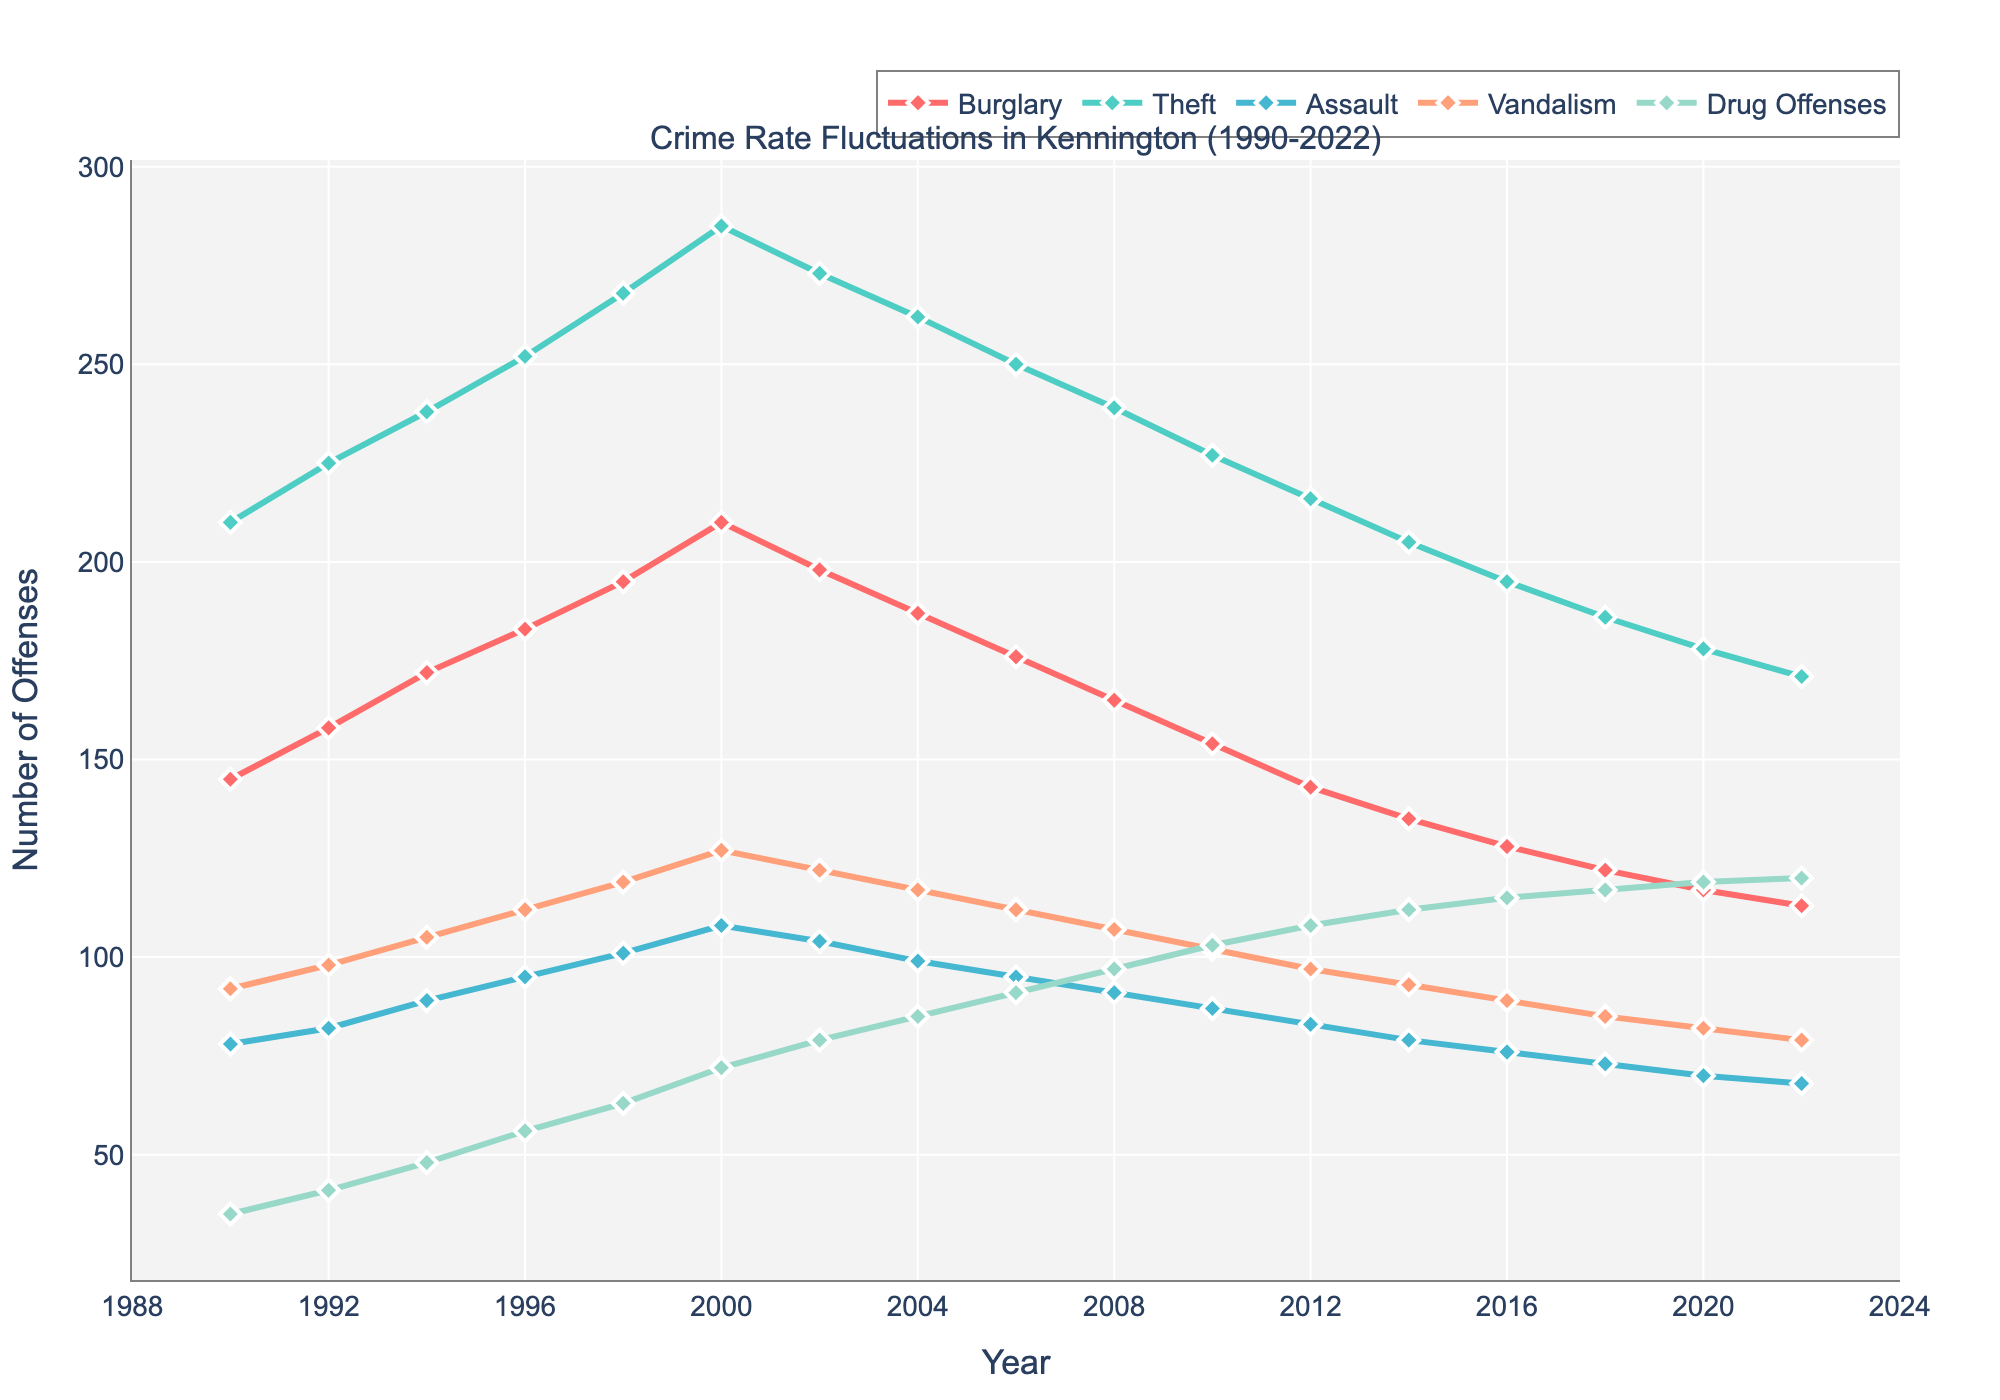What's the trend in burglary rates from 1990 to 2022? To observe the trend of burglary rates over the years, note if the line representing burglary is increasing, decreasing, or fluctuating. The burglary rate shows a general decreasing trend from 1990 to 2022.
Answer: General decreasing trend Which offense had the highest number of cases in 1998? Look for the highest point among the lines at the year 1998. The Theft line is at the highest point compared to others.
Answer: Theft In which year did Drug Offenses exceed 110 cases for the first time? Track the Drug Offenses line and find the first year it crosses 110. The Drug Offenses line exceeds 110 for the first time in 2018.
Answer: 2018 How do the number of theft cases in 1994 compare to the number of assault cases in 1994? Locate 1994 on the x-axis and compare the y-values of Theft and Assault. The number of Theft cases is higher than Assault cases in 1994.
Answer: Higher What's the difference between the peak burglary rate and the lowest burglary rate from 1990 to 2022? Identify the highest and lowest points of the Burglary line and calculate the difference between them. The peak burglary rate is 210 in 2000 and the lowest is 113 in 2022. The difference is 210 - 113.
Answer: 97 Which crime type shows the most significant increase from 1990 to 2022? Compare the beginning and end points of each crime's line. Drug Offenses increased from 35 in 1990 to 120 in 2022 which is the most significant increase.
Answer: Drug Offenses Between 1994 and 2000, did vandalism rates increase or decrease? Check the trend of the Vandalism line between 1994 and 2000. The vandalism rates show an increasing trend from 1994 to 2000.
Answer: Increase Are there any periods where the number of assault cases remains constant? Observe the Assault line for any horizontal segments. The number of assault cases does not remain completely constant at any period; it slightly fluctuates throughout.
Answer: No What's the average number of drug offenses from 1990 to 2000? Sum the Drug Offense values from 1990 to 2000 and divide by the number of years. The sum is 35 + 41 + 48 + 56 + 63 + 72 = 315. The number of years is 6 + 1 = 7. So, 315 / 7 = 45.
Answer: 45 Which crime type had the steepest decline from 2000 to 2022? Compare the slope of the decline for each crime type from 2000 to 2022. Burglary had the steepest decline from around 210 to 113.
Answer: Burglary 